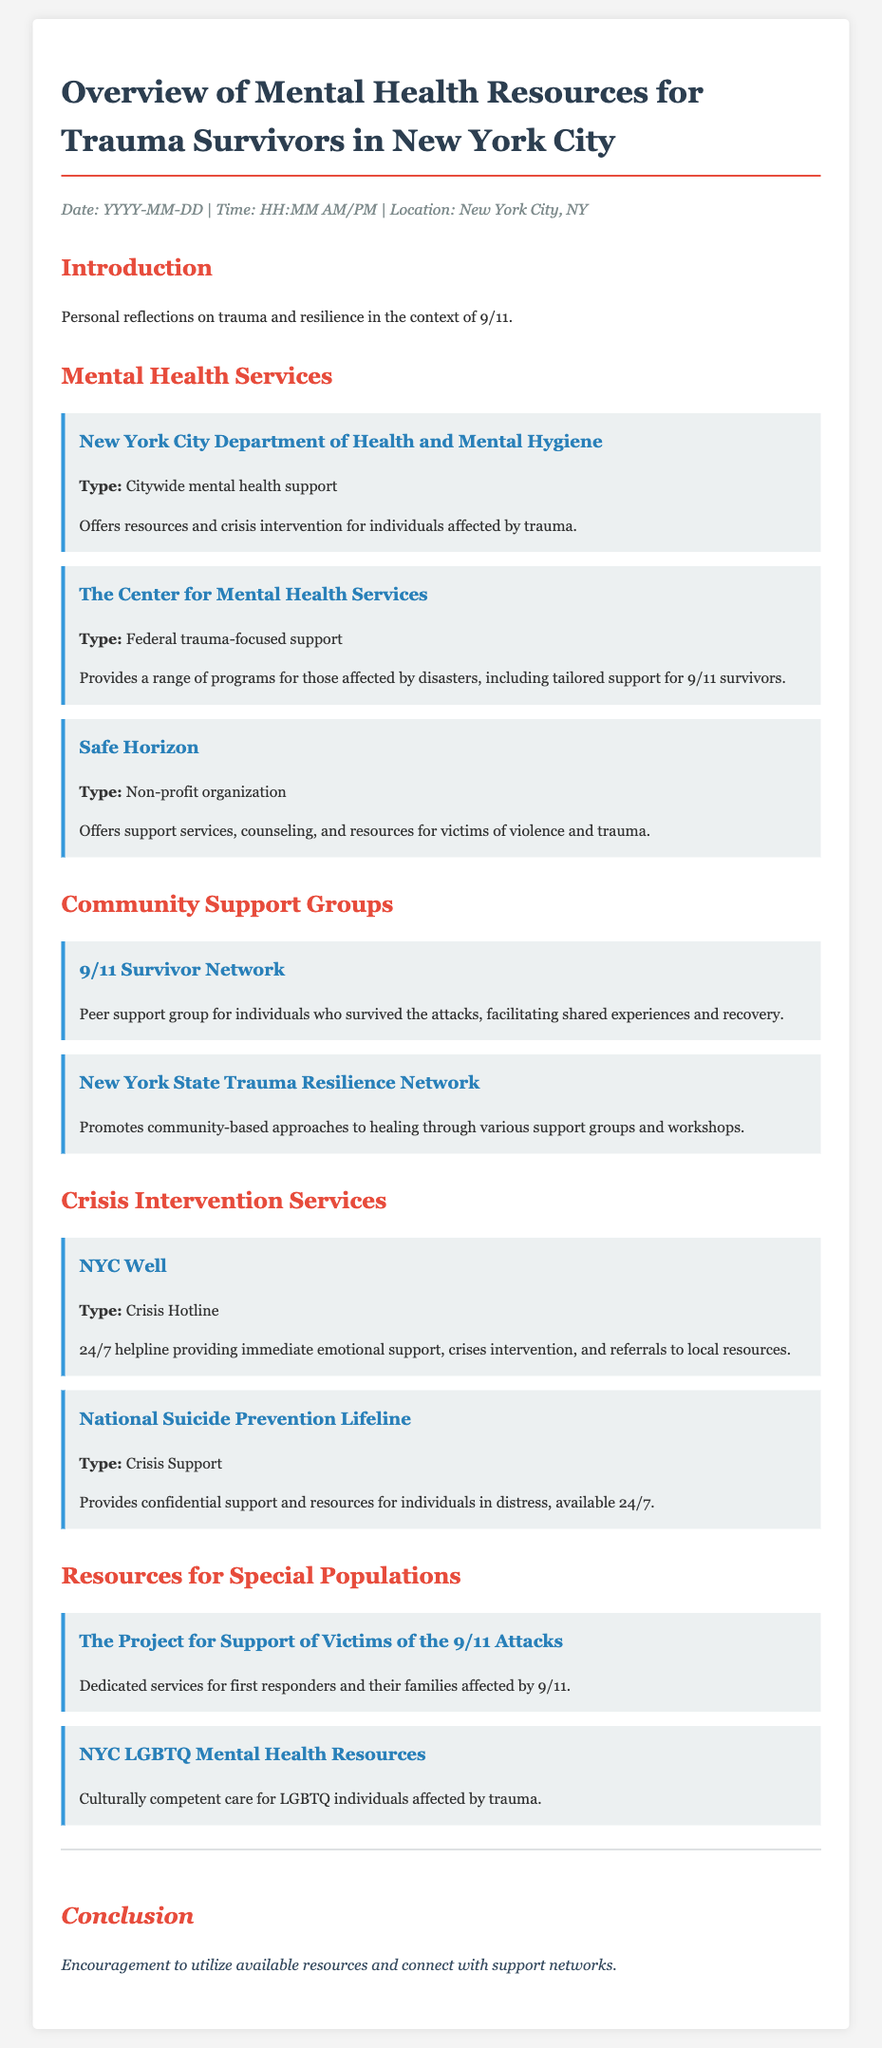What is the title of the document? The title is mentioned in the heading of the document, which refers to mental health resources for trauma survivors in New York City.
Answer: Overview of Mental Health Resources for Trauma Survivors in New York City What organization offers citywide mental health support? The document mentions organizations under the section on mental health services, highlighting their roles.
Answer: New York City Department of Health and Mental Hygiene What type of support does Safe Horizon provide? The document describes Safe Horizon as a non-profit organization offering various services related to trauma.
Answer: Support services, counseling, and resources for victims of violence and trauma How many community support groups are listed? By counting the groups mentioned in the community support sections, we determine the total number.
Answer: Two What is the 24/7 crisis hotline mentioned in the document? The document specifies the crisis hotline available for immediate emotional support, identifying it clearly.
Answer: NYC Well What resources are available for LGBTQ individuals? The document specifically points to resources tailored for a particular population affected by trauma.
Answer: NYC LGBTQ Mental Health Resources Which network promotes community-based approaches to healing? This question addresses the groups mentioned under community support and seeks to identify one of them.
Answer: New York State Trauma Resilience Network What type of services does The Project for Support of Victims of the 9/11 Attacks offer? The document details the specific focus of the services offered by this project regarding a particular group.
Answer: Dedicated services for first responders and their families affected by 9/11 What is the general conclusion given in the document? The conclusion section wraps up the overall message intended by the document regarding resource utilization.
Answer: Encouragement to utilize available resources and connect with support networks 